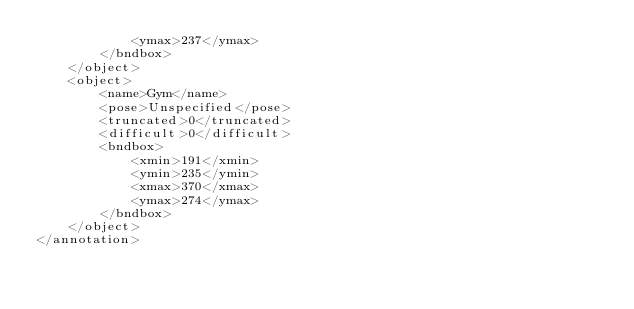Convert code to text. <code><loc_0><loc_0><loc_500><loc_500><_XML_>			<ymax>237</ymax>
		</bndbox>
	</object>
	<object>
		<name>Gym</name>
		<pose>Unspecified</pose>
		<truncated>0</truncated>
		<difficult>0</difficult>
		<bndbox>
			<xmin>191</xmin>
			<ymin>235</ymin>
			<xmax>370</xmax>
			<ymax>274</ymax>
		</bndbox>
	</object>
</annotation>
</code> 